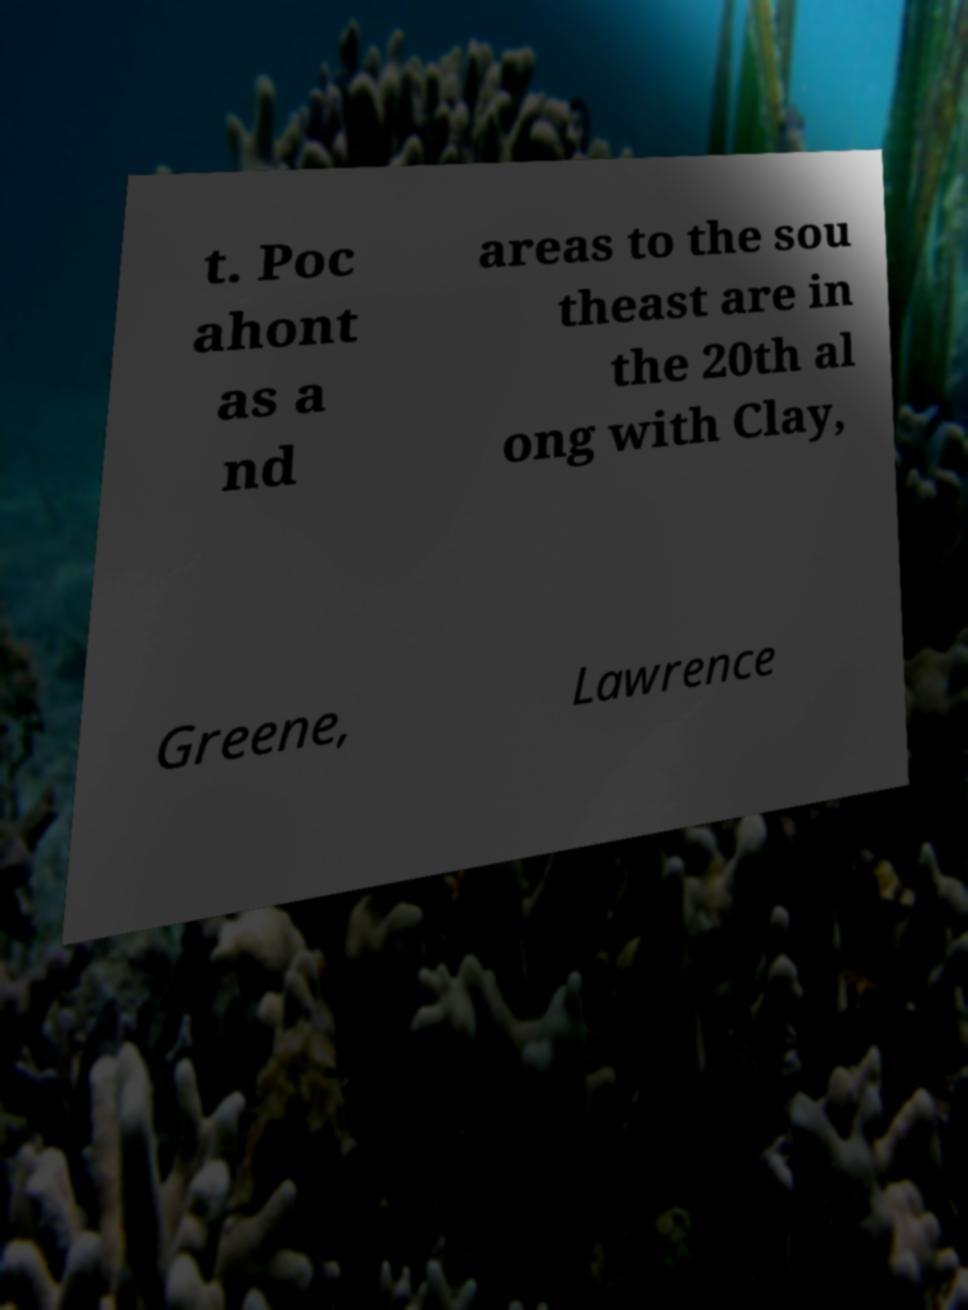What messages or text are displayed in this image? I need them in a readable, typed format. t. Poc ahont as a nd areas to the sou theast are in the 20th al ong with Clay, Greene, Lawrence 